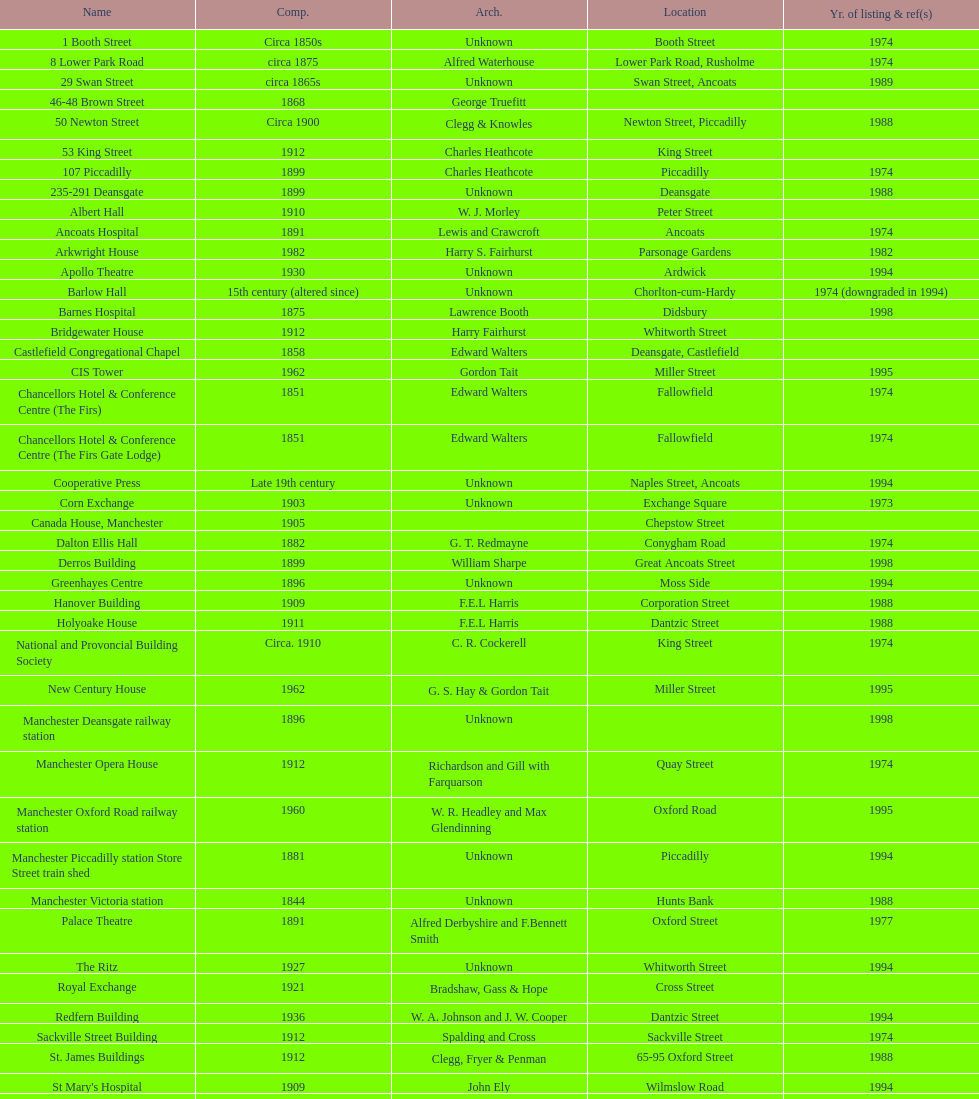What is the difference, in years, between the completion dates of 53 king street and castlefield congregational chapel? 54 years. 